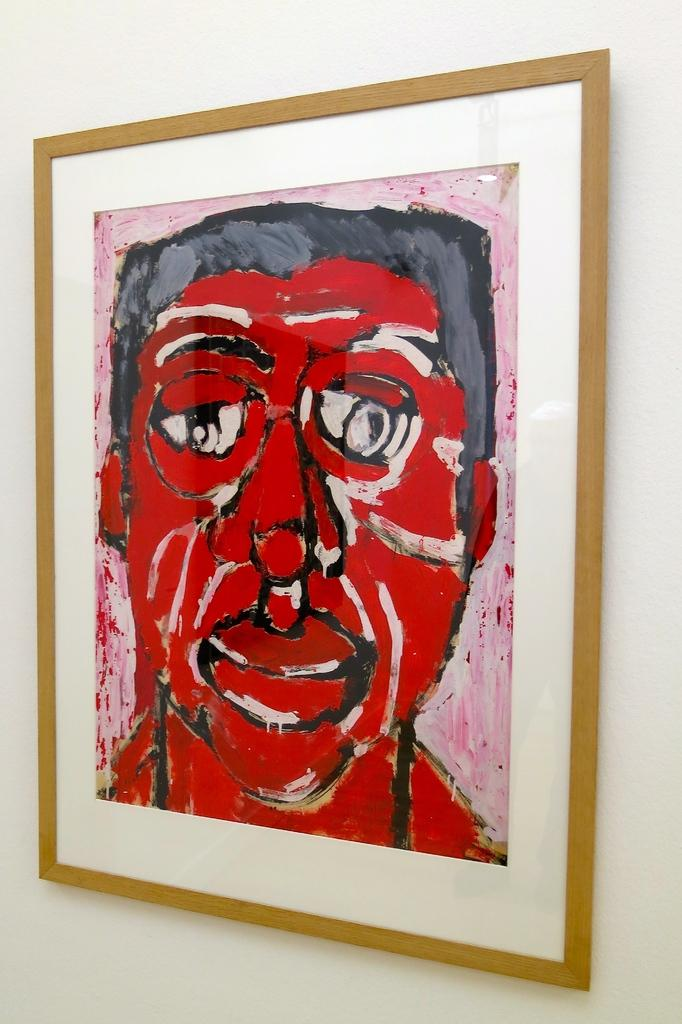What is the main subject in the center of the image? There is a portrait in the image, and it is in the center of the image. What is depicted in the portrait? The subject of the portrait is a man. How many steps does the man in the portrait take in the image? There are no steps or any indication of movement in the image, as it features a portrait of a man. What type of baseball equipment can be seen in the image? There is no baseball equipment present in the image; it features a portrait of a man. 